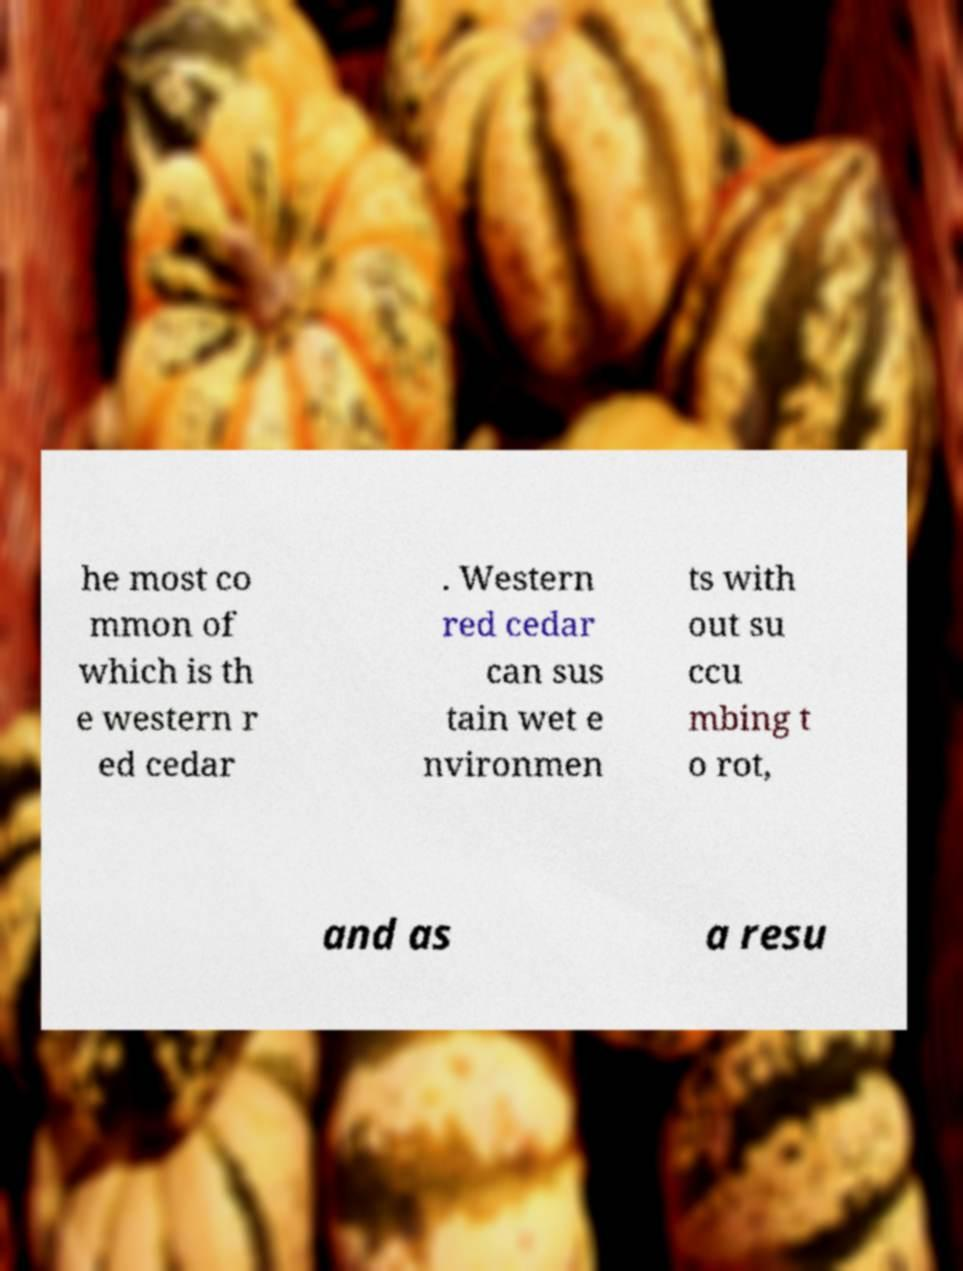Can you accurately transcribe the text from the provided image for me? he most co mmon of which is th e western r ed cedar . Western red cedar can sus tain wet e nvironmen ts with out su ccu mbing t o rot, and as a resu 